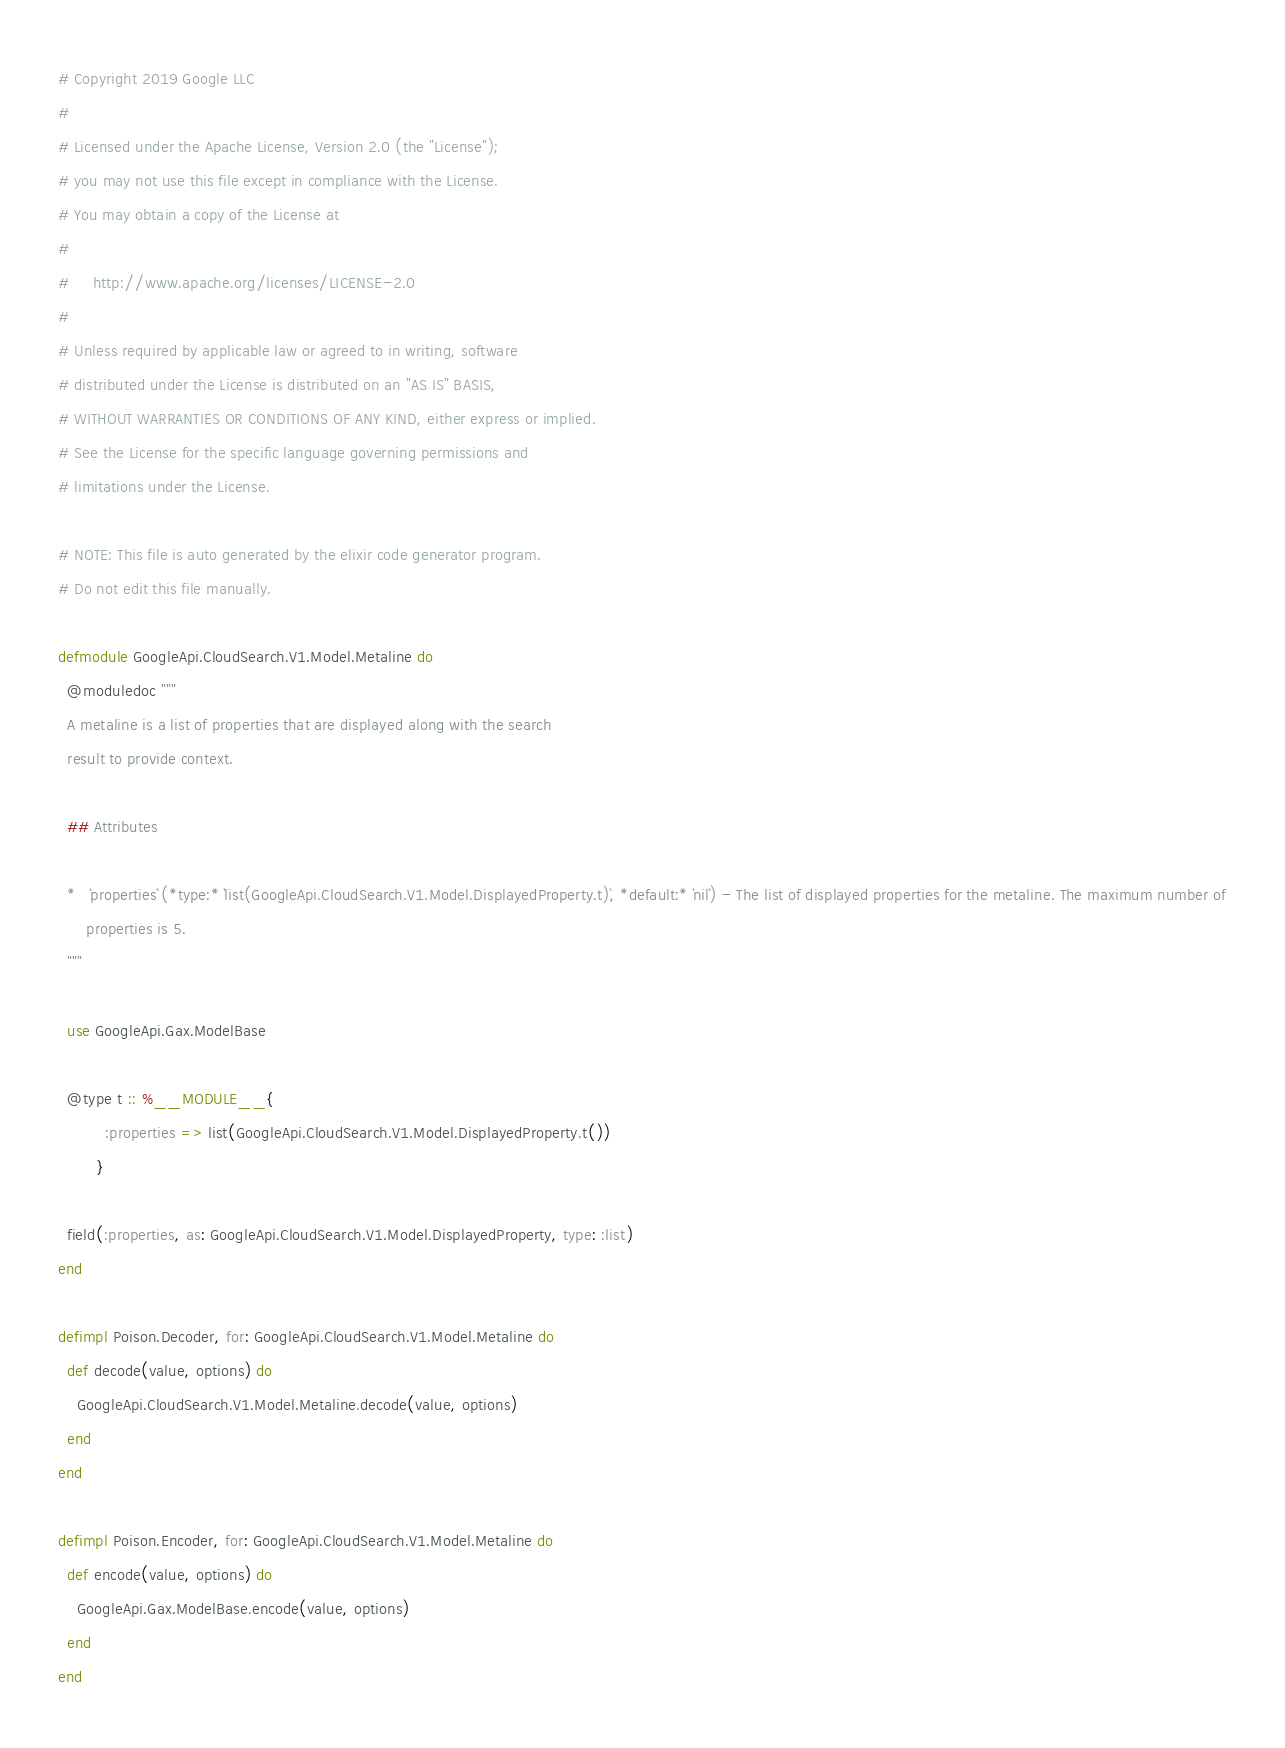<code> <loc_0><loc_0><loc_500><loc_500><_Elixir_># Copyright 2019 Google LLC
#
# Licensed under the Apache License, Version 2.0 (the "License");
# you may not use this file except in compliance with the License.
# You may obtain a copy of the License at
#
#     http://www.apache.org/licenses/LICENSE-2.0
#
# Unless required by applicable law or agreed to in writing, software
# distributed under the License is distributed on an "AS IS" BASIS,
# WITHOUT WARRANTIES OR CONDITIONS OF ANY KIND, either express or implied.
# See the License for the specific language governing permissions and
# limitations under the License.

# NOTE: This file is auto generated by the elixir code generator program.
# Do not edit this file manually.

defmodule GoogleApi.CloudSearch.V1.Model.Metaline do
  @moduledoc """
  A metaline is a list of properties that are displayed along with the search
  result to provide context.

  ## Attributes

  *   `properties` (*type:* `list(GoogleApi.CloudSearch.V1.Model.DisplayedProperty.t)`, *default:* `nil`) - The list of displayed properties for the metaline. The maximum number of
      properties is 5.
  """

  use GoogleApi.Gax.ModelBase

  @type t :: %__MODULE__{
          :properties => list(GoogleApi.CloudSearch.V1.Model.DisplayedProperty.t())
        }

  field(:properties, as: GoogleApi.CloudSearch.V1.Model.DisplayedProperty, type: :list)
end

defimpl Poison.Decoder, for: GoogleApi.CloudSearch.V1.Model.Metaline do
  def decode(value, options) do
    GoogleApi.CloudSearch.V1.Model.Metaline.decode(value, options)
  end
end

defimpl Poison.Encoder, for: GoogleApi.CloudSearch.V1.Model.Metaline do
  def encode(value, options) do
    GoogleApi.Gax.ModelBase.encode(value, options)
  end
end
</code> 